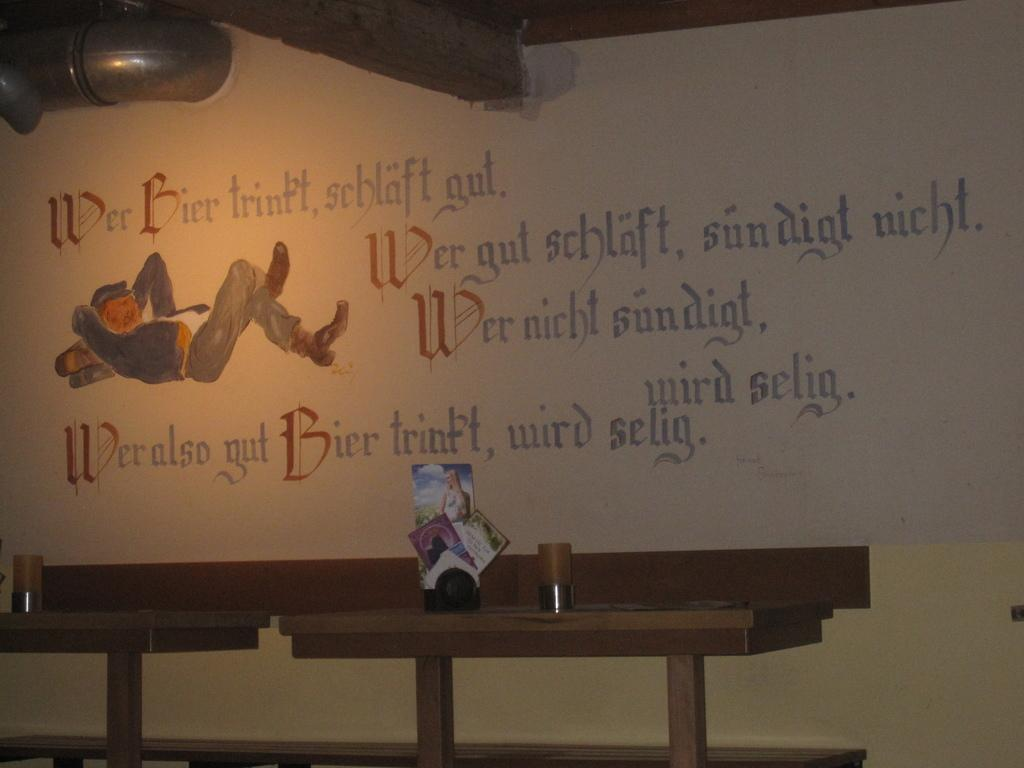Provide a one-sentence caption for the provided image. A mural with a man on his back relaxing has a passage that begins with "Wer Bier.". 